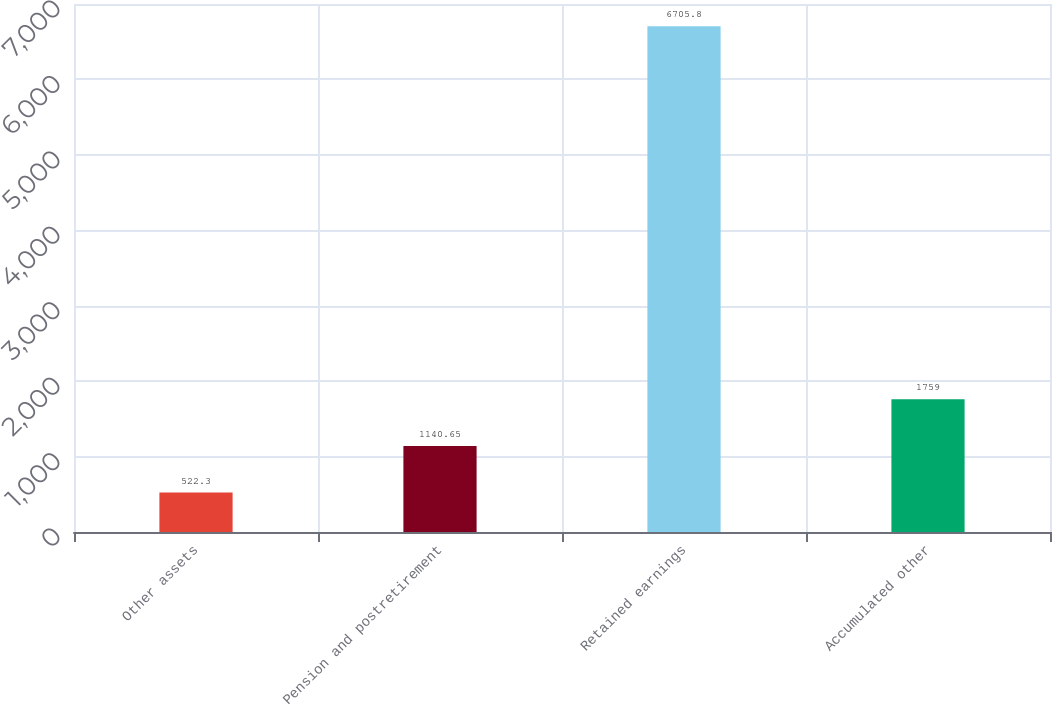Convert chart to OTSL. <chart><loc_0><loc_0><loc_500><loc_500><bar_chart><fcel>Other assets<fcel>Pension and postretirement<fcel>Retained earnings<fcel>Accumulated other<nl><fcel>522.3<fcel>1140.65<fcel>6705.8<fcel>1759<nl></chart> 